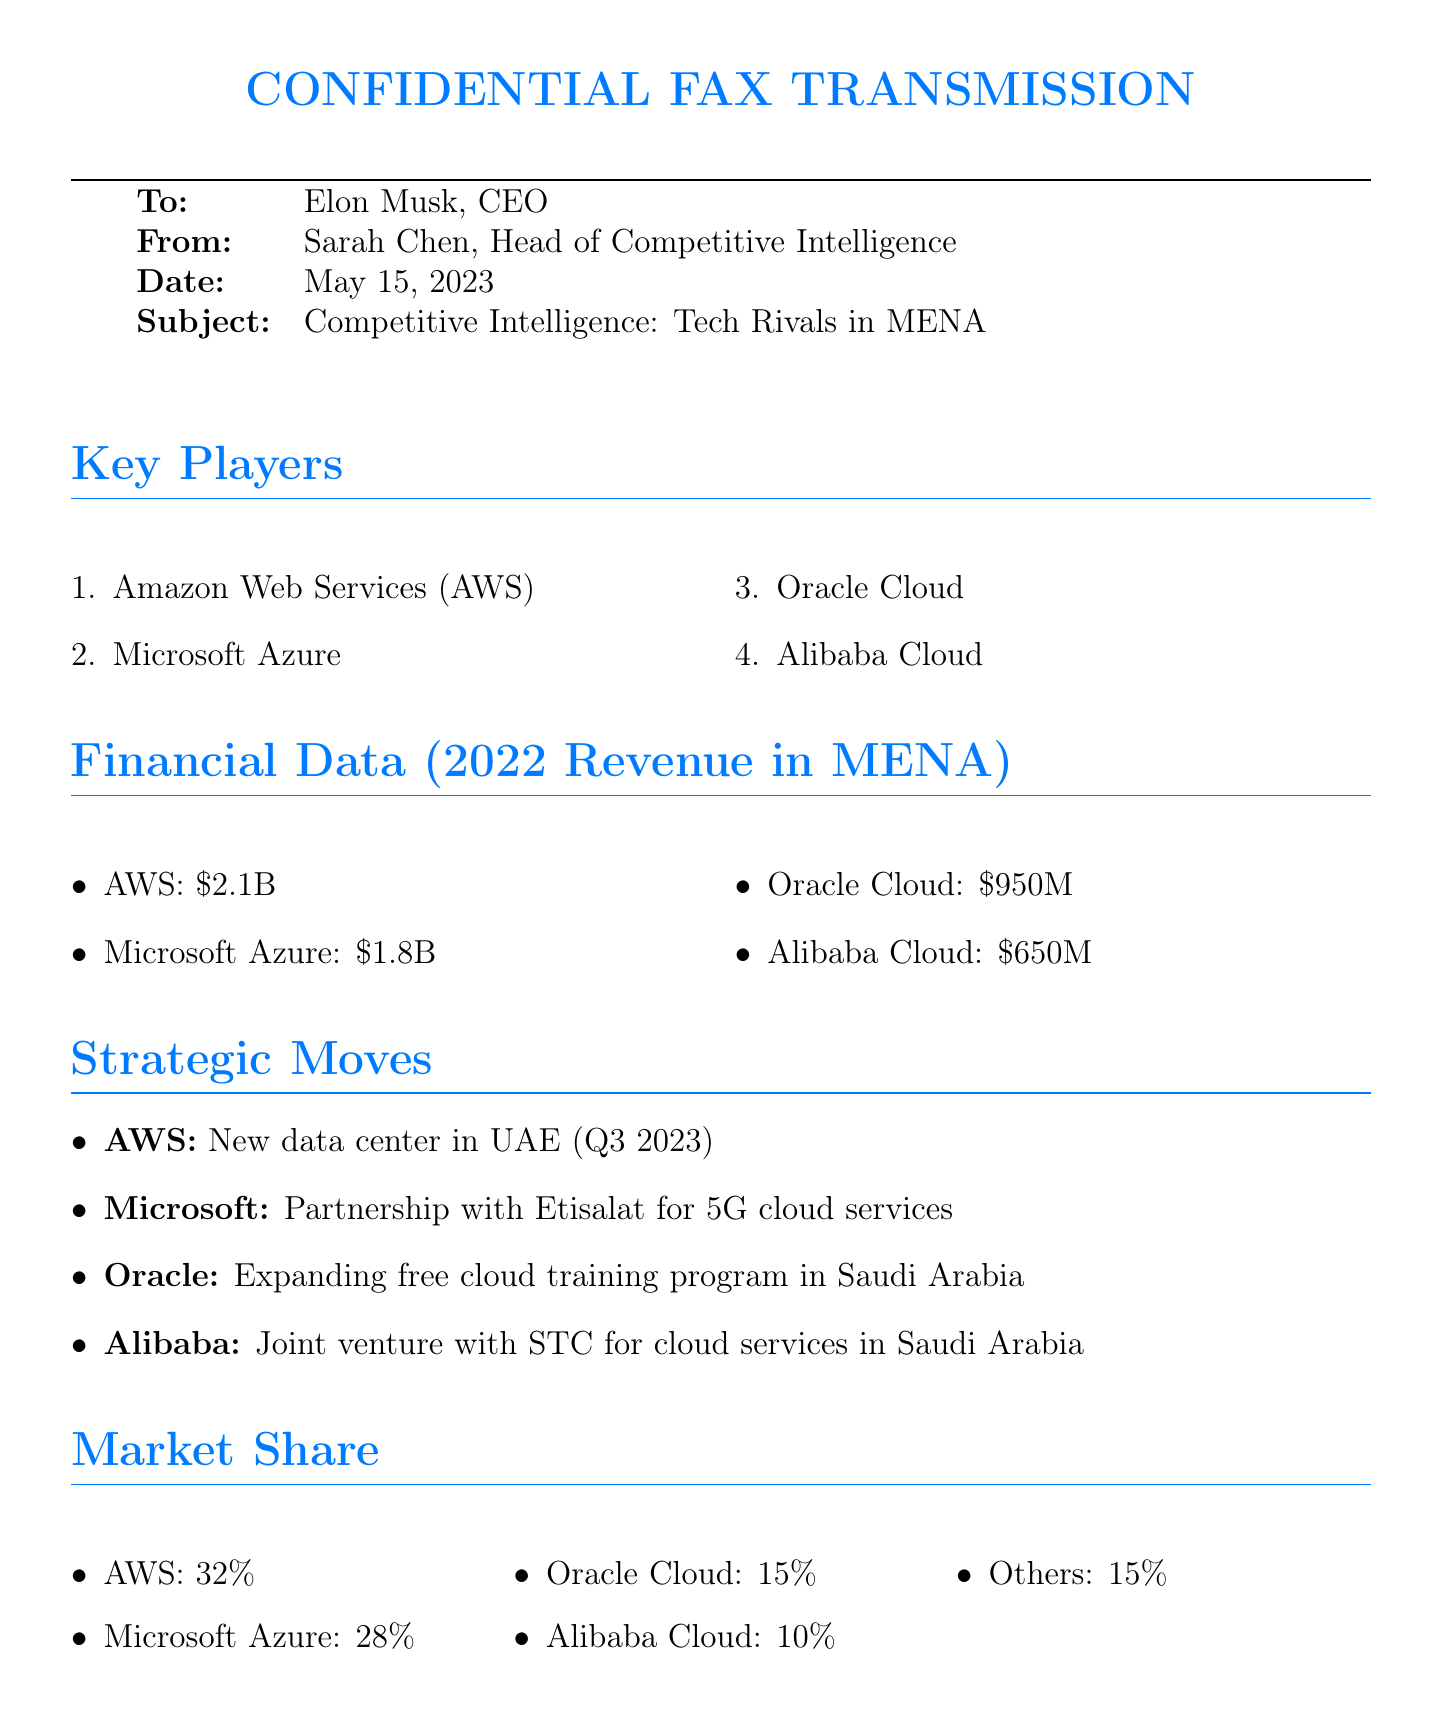What is the date of the fax? The date is mentioned at the top of the document under the "Date" field.
Answer: May 15, 2023 Who is the sender of the fax? The sender's name is provided in the "From" field in the header of the document.
Answer: Sarah Chen What is the revenue of Oracle Cloud in MENA for 2022? The revenue figure is listed specifically in the "Financial Data" section of the document.
Answer: $950M Which company has the largest market share? Market share information can be found in the "Market Share" section, which lists the percentages for each company.
Answer: AWS What strategic move did Microsoft make in the MENA region? The strategic moves are listed under "Strategic Moves" and specifically mention what each company is doing.
Answer: Partnership with Etisalat for 5G cloud services What are the key growth areas mentioned? The key growth areas are listed in a specific section identifying the main opportunities in the market.
Answer: Fintech solutions How many companies are listed in the key players section? The number of listed companies is given in the "Key Players" section of the document.
Answer: 4 Which company has a joint venture with STC? This information can be found under the strategic moves where each company's activities are mentioned.
Answer: Alibaba What is the revenue of AWS in MENA for 2022? This information is provided in the "Financial Data" section, indicating the revenue for AWS.
Answer: $2.1B 